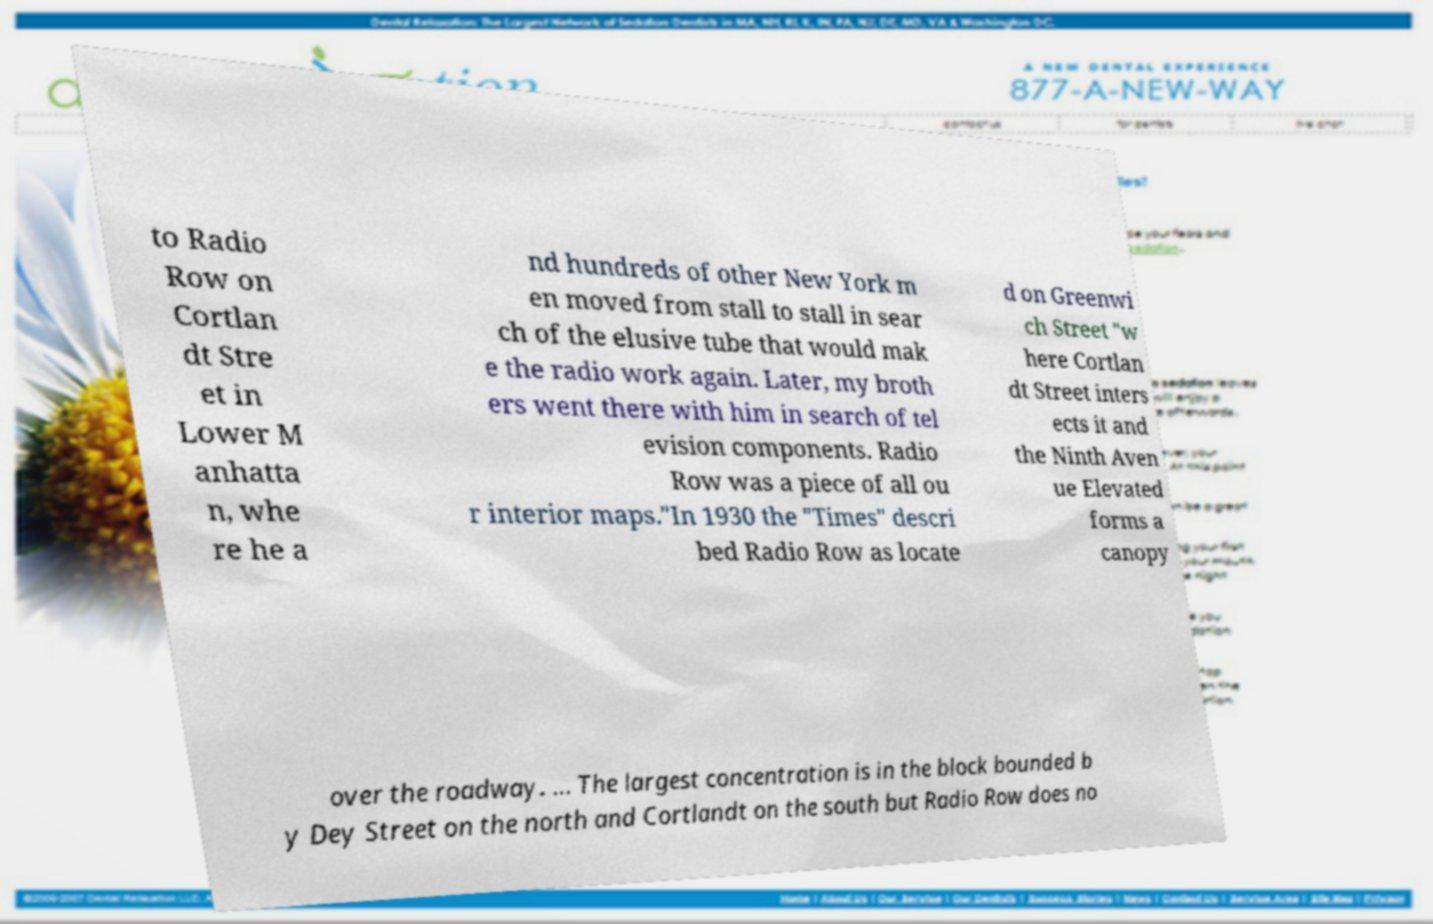Please identify and transcribe the text found in this image. to Radio Row on Cortlan dt Stre et in Lower M anhatta n, whe re he a nd hundreds of other New York m en moved from stall to stall in sear ch of the elusive tube that would mak e the radio work again. Later, my broth ers went there with him in search of tel evision components. Radio Row was a piece of all ou r interior maps."In 1930 the "Times" descri bed Radio Row as locate d on Greenwi ch Street "w here Cortlan dt Street inters ects it and the Ninth Aven ue Elevated forms a canopy over the roadway. ... The largest concentration is in the block bounded b y Dey Street on the north and Cortlandt on the south but Radio Row does no 